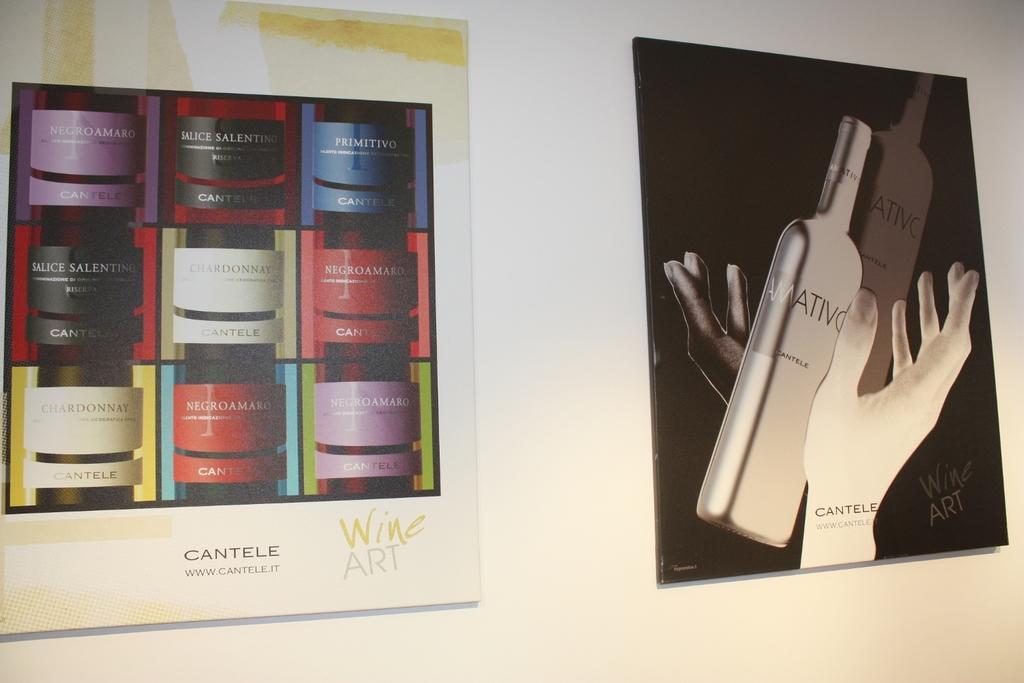Please provide a concise description of this image. There is a wall. On the wall there are photo frames. On the right side there is a photo frame. On that photo frame we can see bottles and hands of a person. 